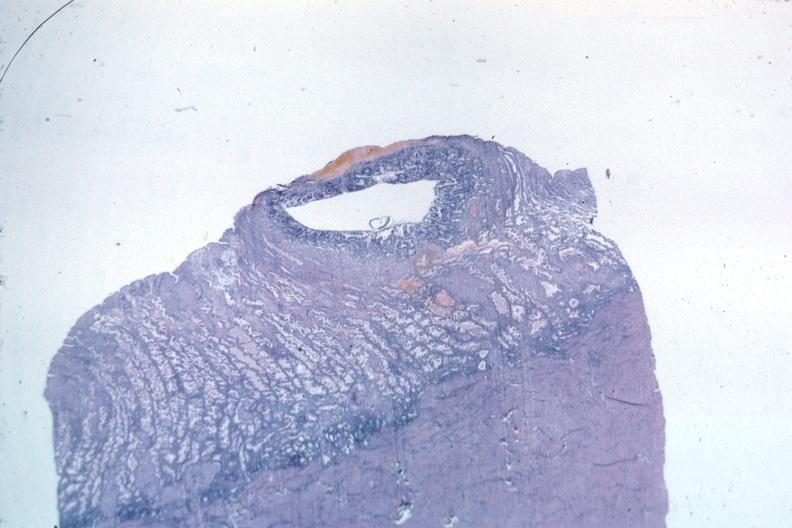what is present?
Answer the question using a single word or phrase. Fetus developing very early 